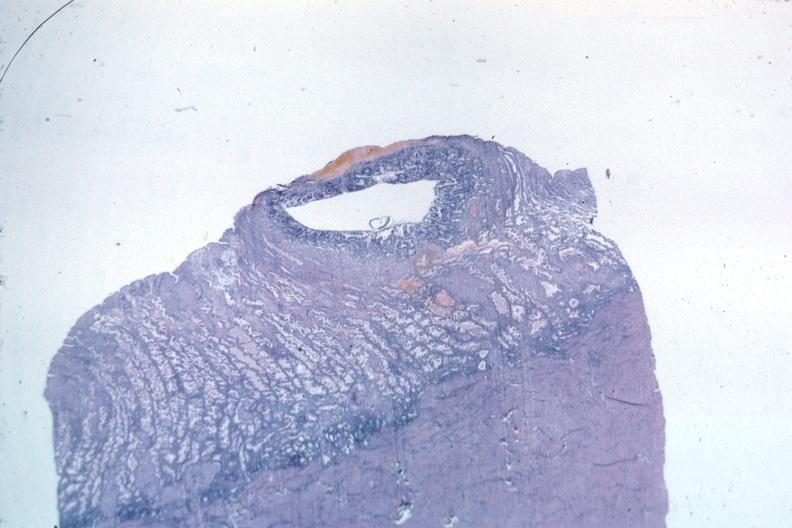what is present?
Answer the question using a single word or phrase. Fetus developing very early 